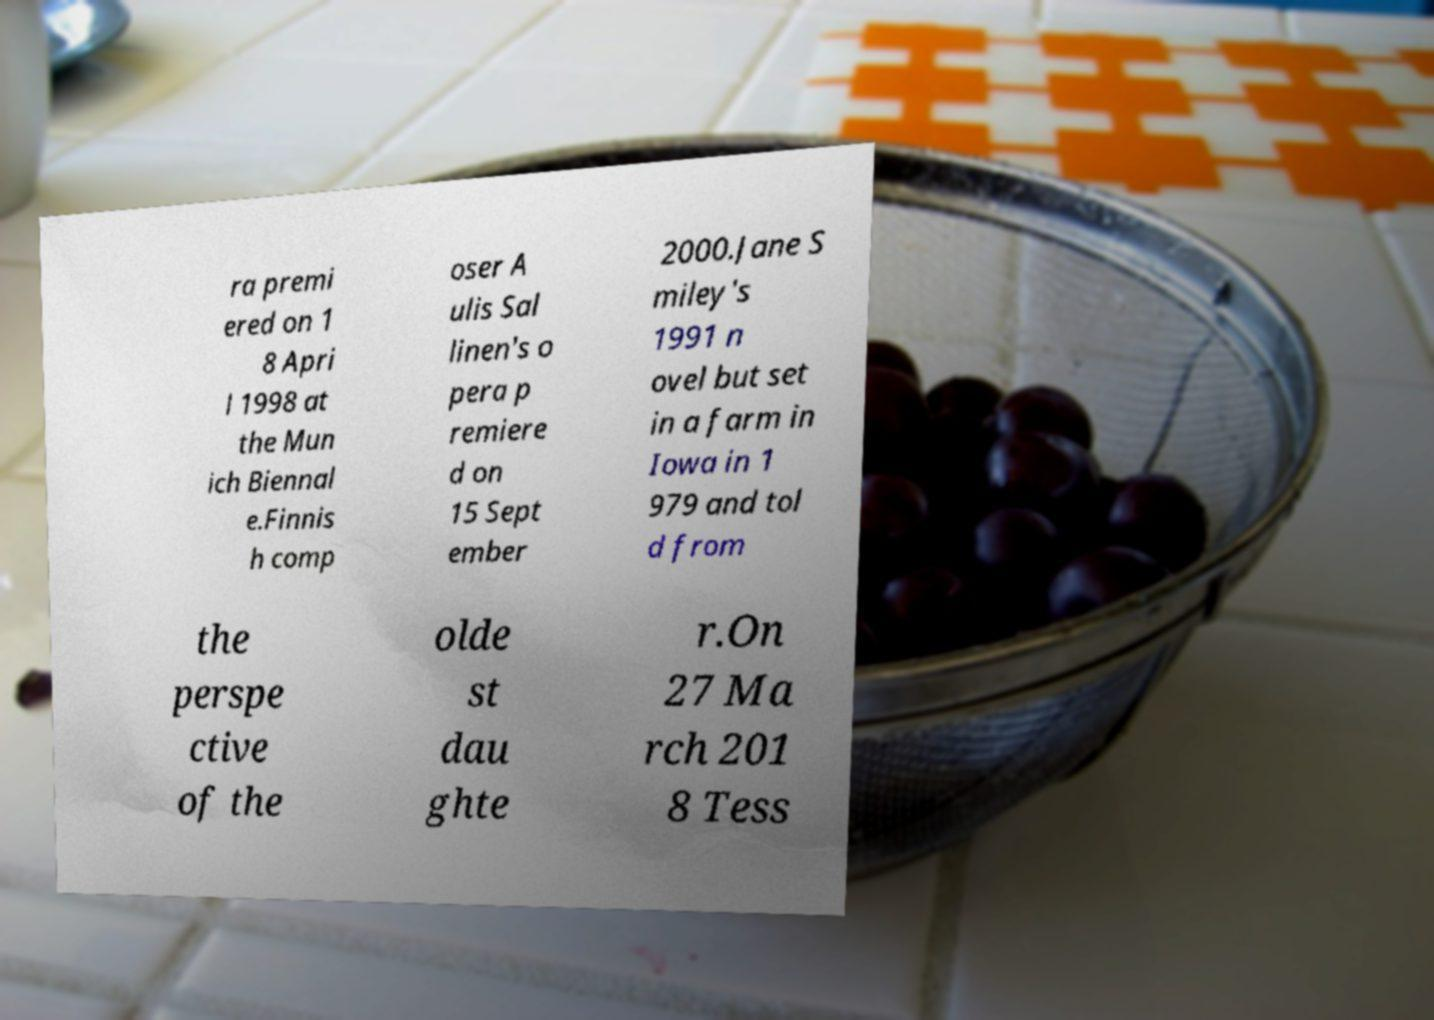Please identify and transcribe the text found in this image. ra premi ered on 1 8 Apri l 1998 at the Mun ich Biennal e.Finnis h comp oser A ulis Sal linen's o pera p remiere d on 15 Sept ember 2000.Jane S miley's 1991 n ovel but set in a farm in Iowa in 1 979 and tol d from the perspe ctive of the olde st dau ghte r.On 27 Ma rch 201 8 Tess 